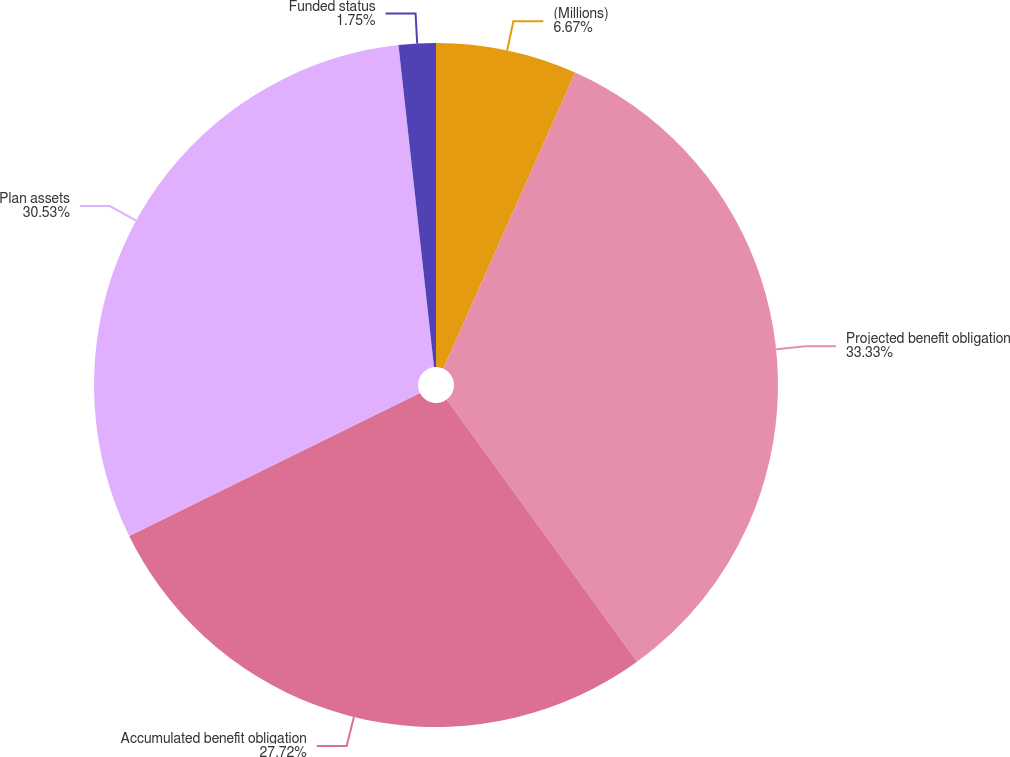Convert chart. <chart><loc_0><loc_0><loc_500><loc_500><pie_chart><fcel>(Millions)<fcel>Projected benefit obligation<fcel>Accumulated benefit obligation<fcel>Plan assets<fcel>Funded status<nl><fcel>6.67%<fcel>33.33%<fcel>27.72%<fcel>30.53%<fcel>1.75%<nl></chart> 